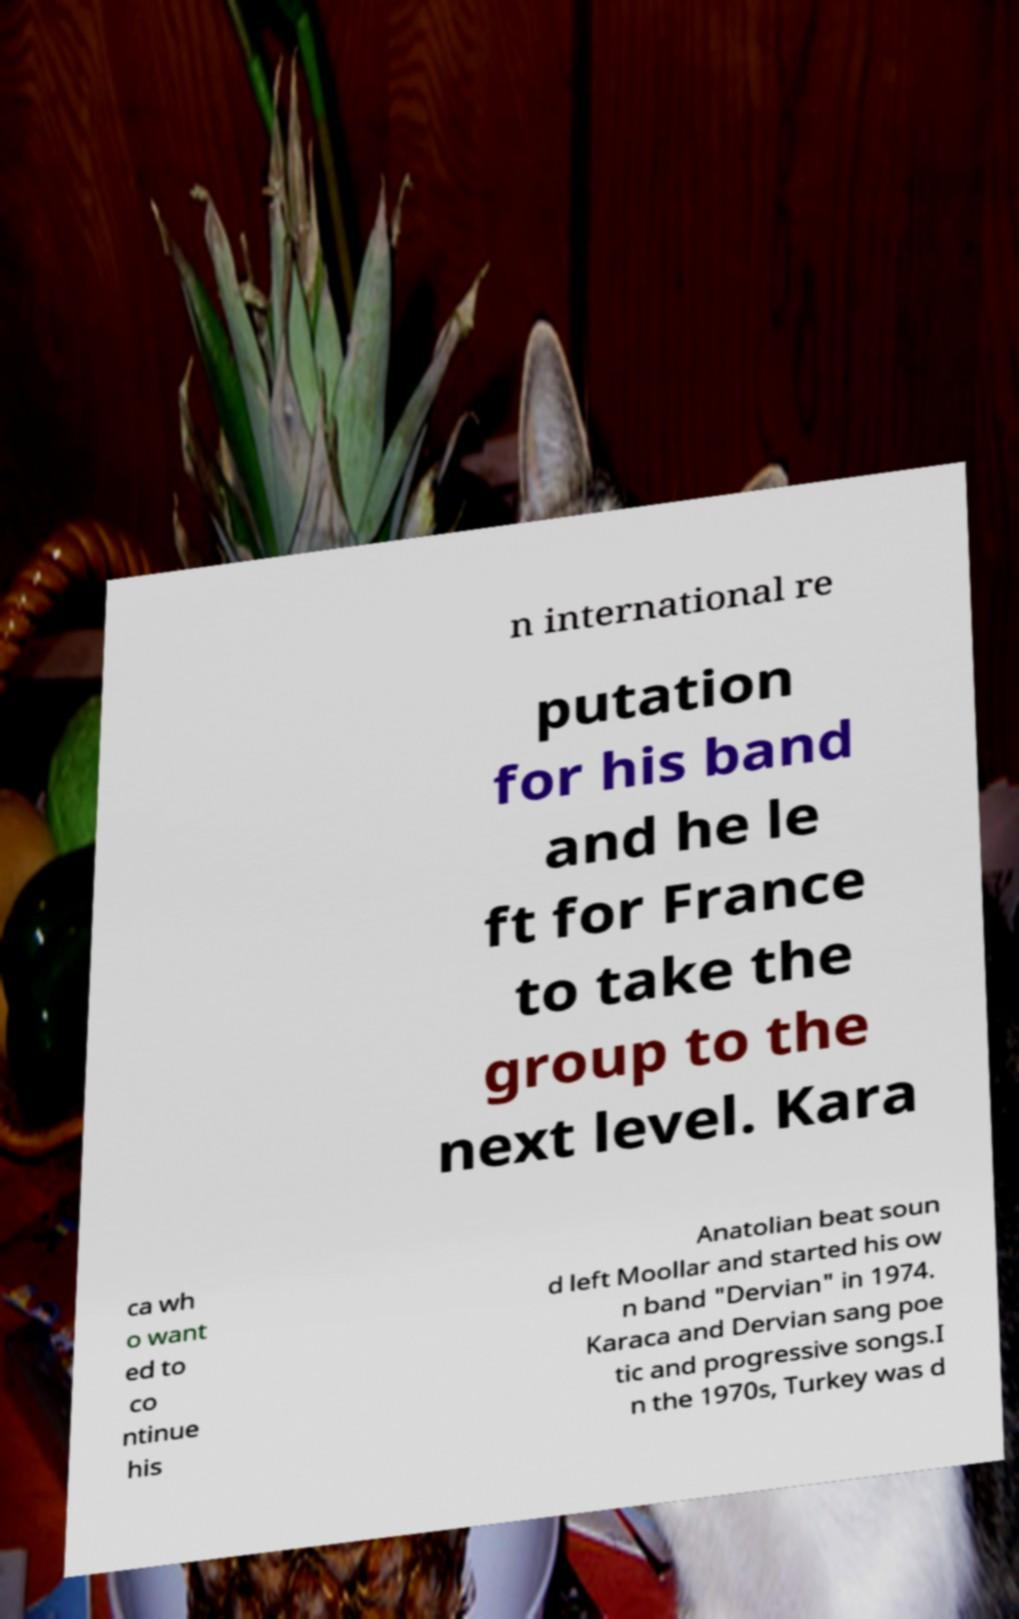Could you extract and type out the text from this image? n international re putation for his band and he le ft for France to take the group to the next level. Kara ca wh o want ed to co ntinue his Anatolian beat soun d left Moollar and started his ow n band "Dervian" in 1974. Karaca and Dervian sang poe tic and progressive songs.I n the 1970s, Turkey was d 